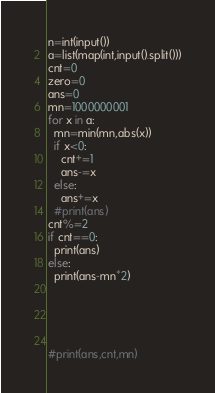Convert code to text. <code><loc_0><loc_0><loc_500><loc_500><_Python_>n=int(input())
a=list(map(int,input().split()))
cnt=0
zero=0
ans=0
mn=1000000001
for x in a:
  mn=min(mn,abs(x))
  if x<0:
    cnt+=1
    ans-=x
  else:
    ans+=x
  #print(ans)
cnt%=2
if cnt==0:
  print(ans)
else:
  print(ans-mn*2)
  
  
  
  
  
#print(ans,cnt,mn)</code> 